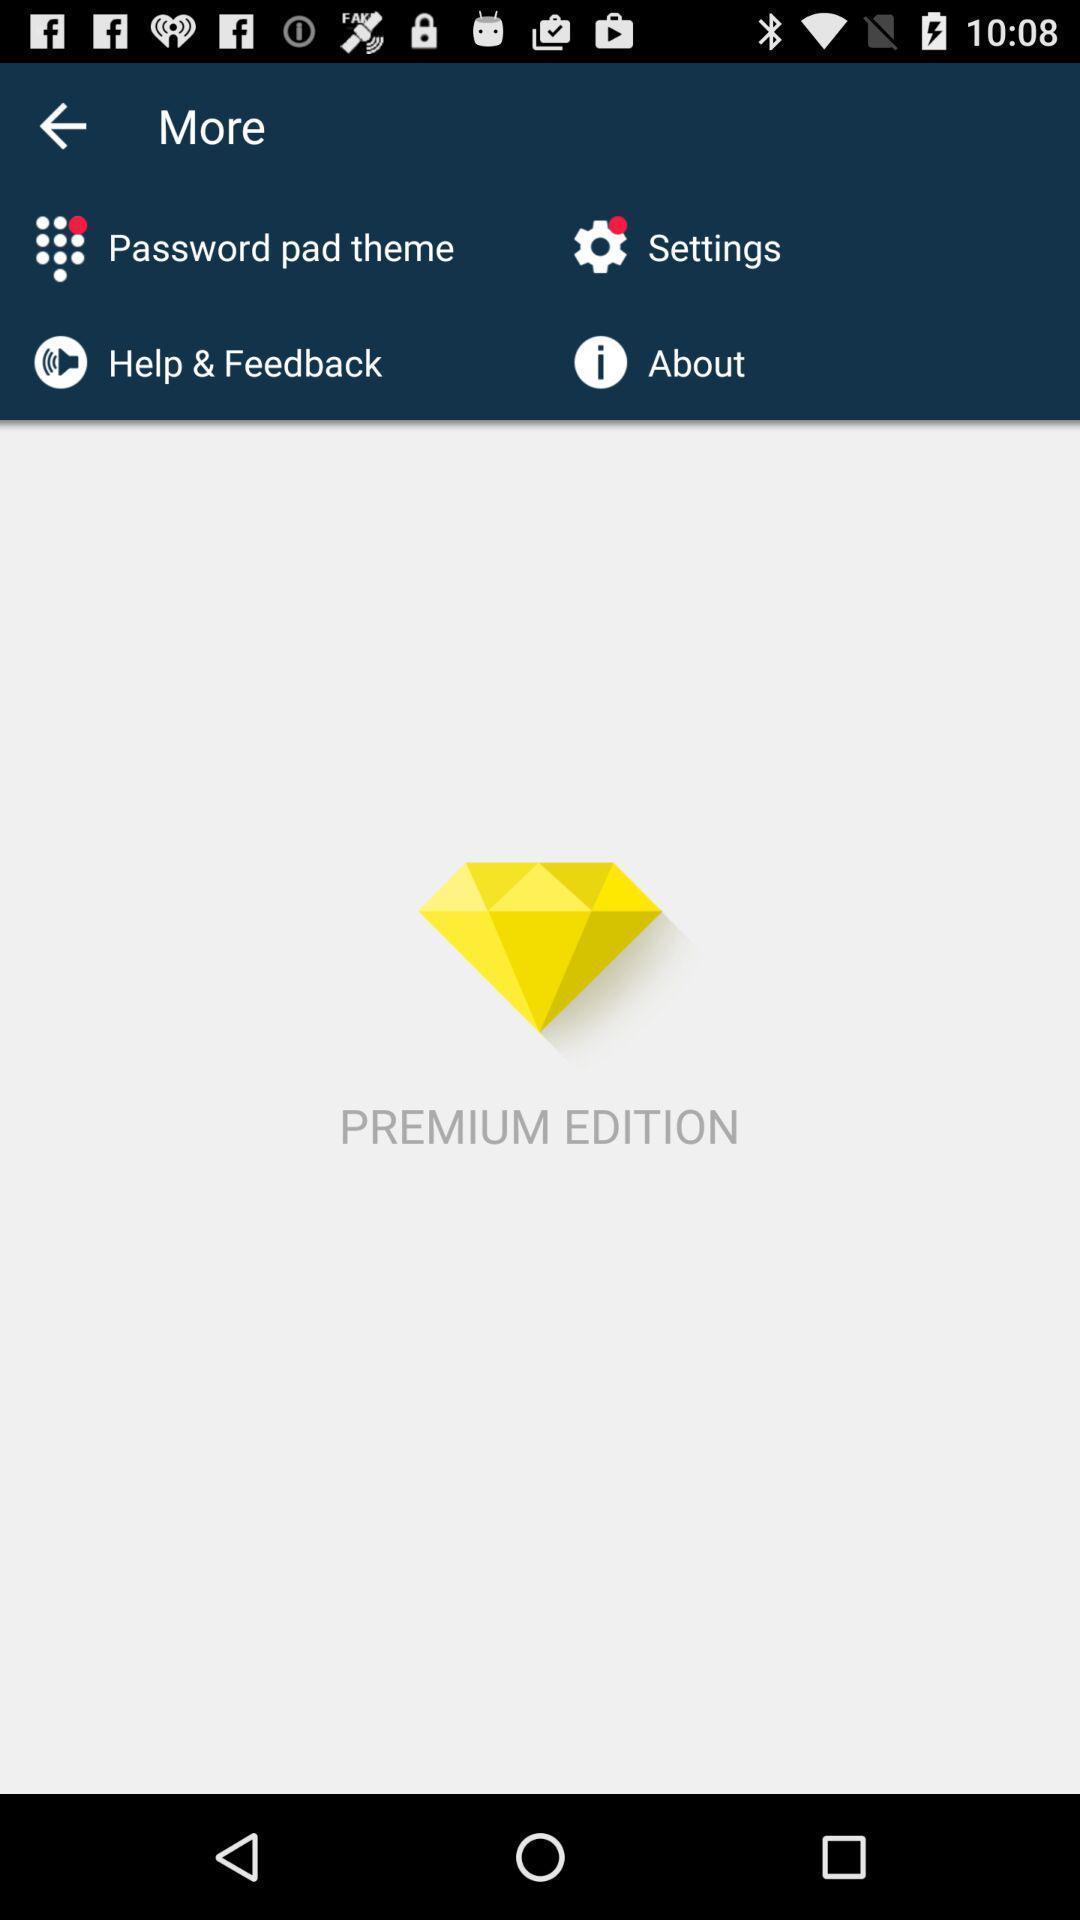Describe the content in this image. Screen showing premium edition. 